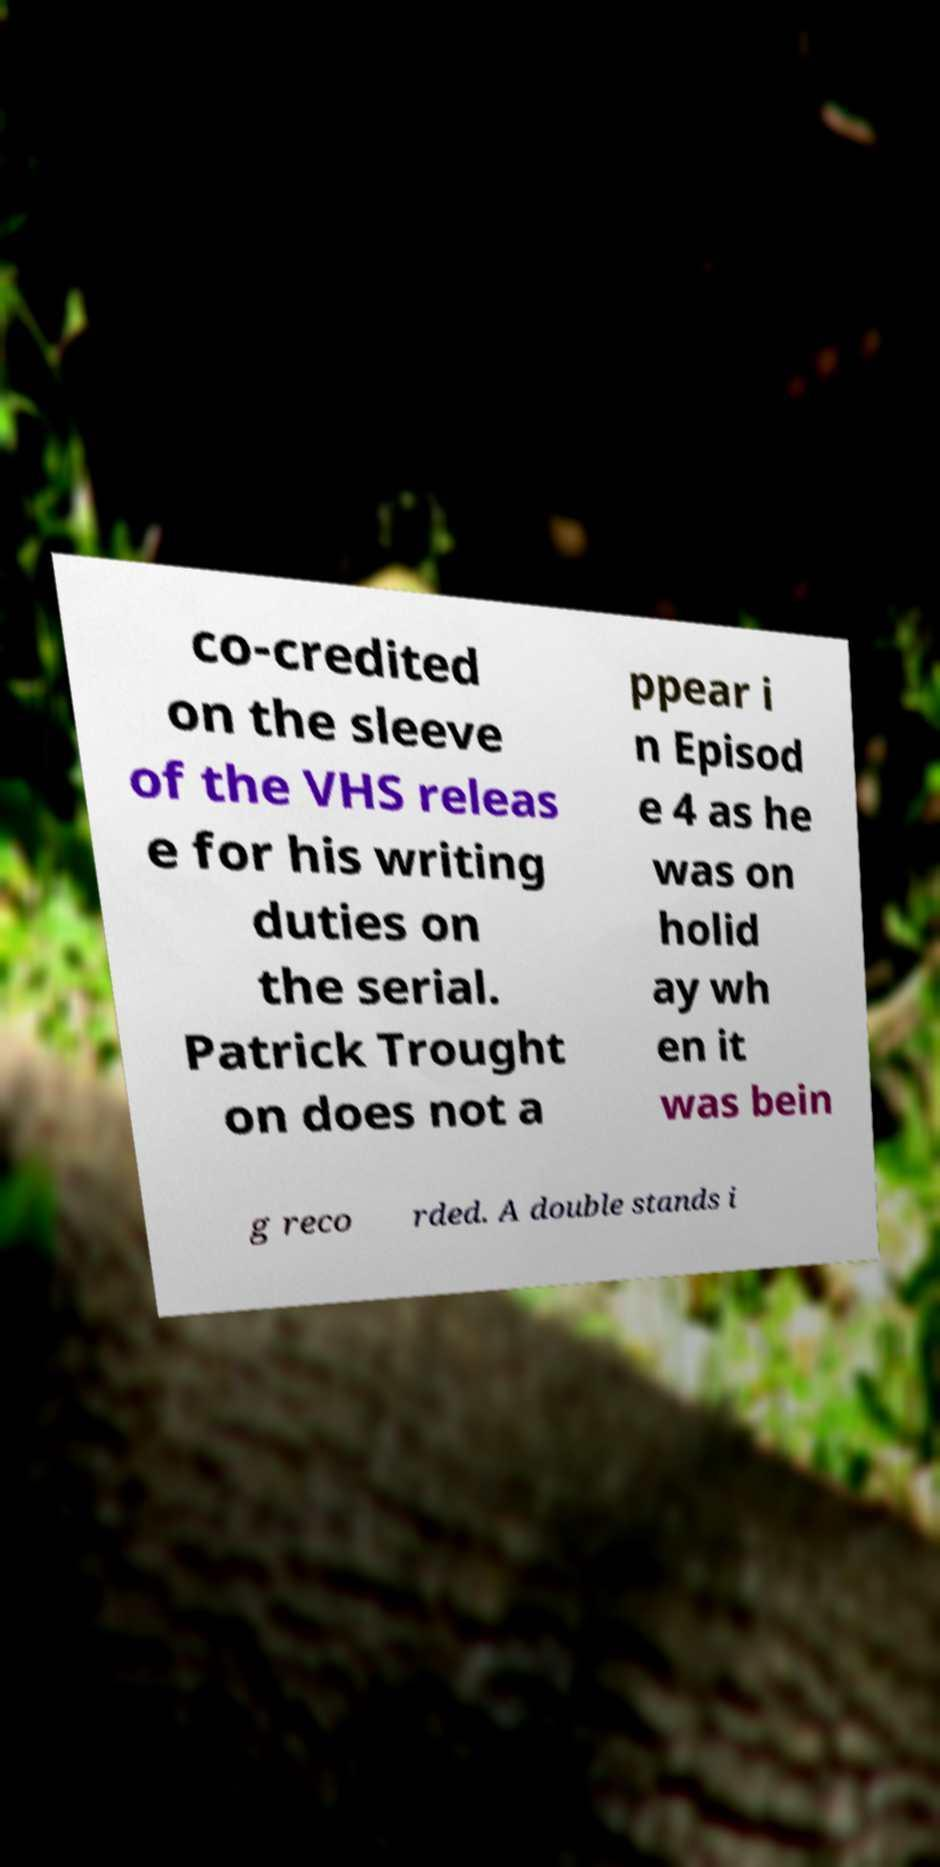Can you accurately transcribe the text from the provided image for me? co-credited on the sleeve of the VHS releas e for his writing duties on the serial. Patrick Trought on does not a ppear i n Episod e 4 as he was on holid ay wh en it was bein g reco rded. A double stands i 